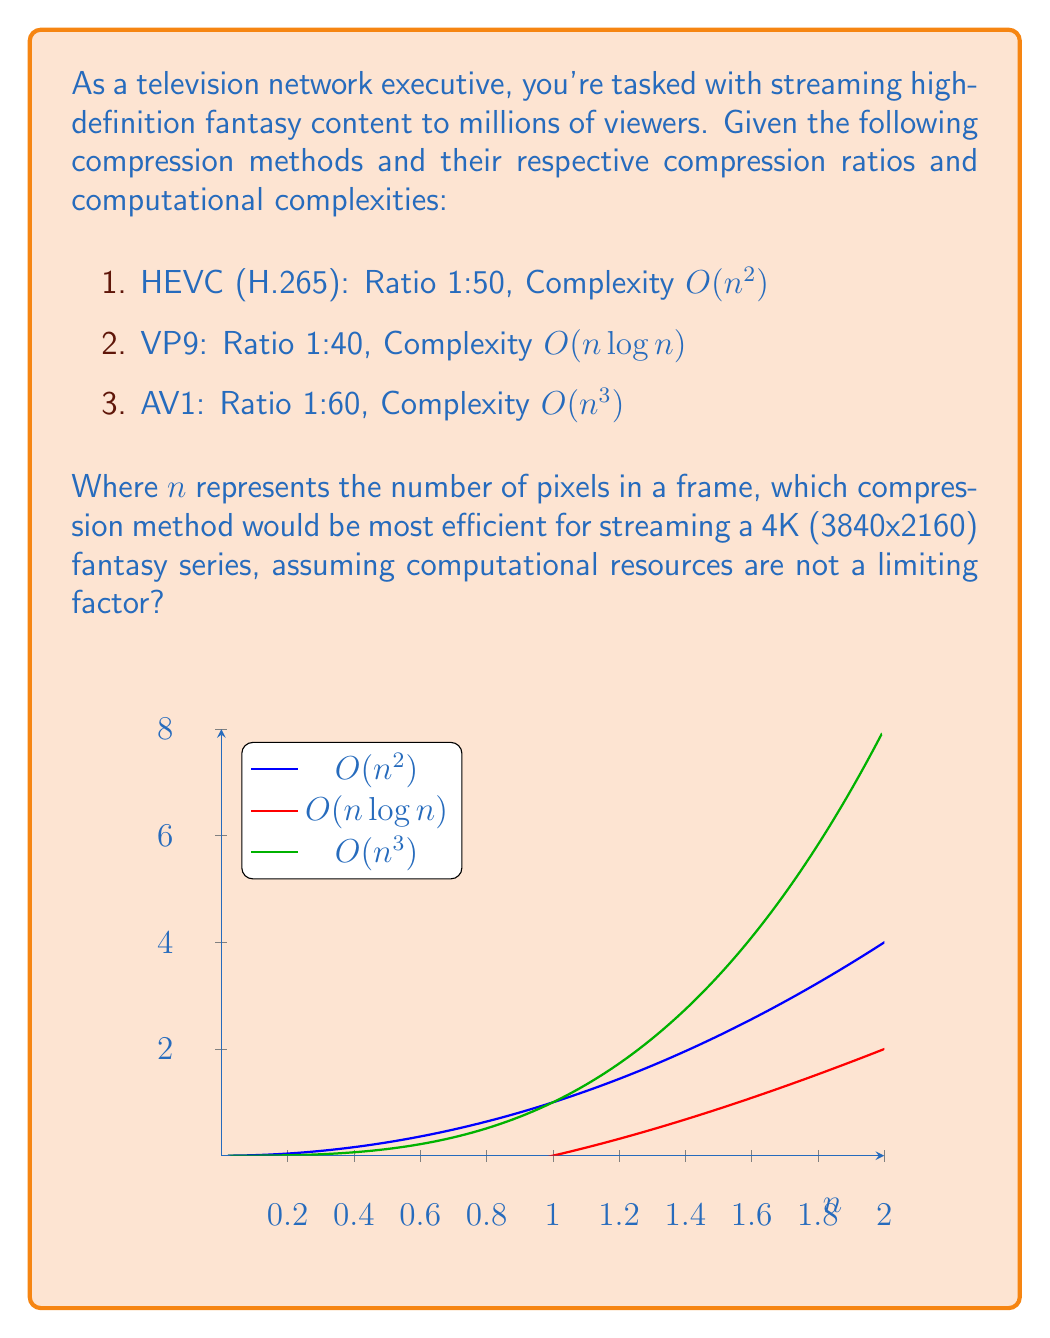What is the answer to this math problem? To determine the most efficient compression method, we need to consider both the compression ratio and the computational complexity. Since computational resources are not a limiting factor, we'll focus primarily on the compression ratio.

Step 1: Calculate the number of pixels in a 4K frame.
$n = 3840 \times 2160 = 8,294,400$ pixels

Step 2: Compare compression ratios:
1. HEVC (H.265): 1:50
2. VP9: 1:40
3. AV1: 1:60

Step 3: Analyze the results:
AV1 has the highest compression ratio at 1:60, meaning it can compress the data the most effectively. This is crucial for streaming high-definition content, as it reduces bandwidth requirements and improves streaming quality.

Step 4: Consider computational complexity:
Although AV1 has the highest computational complexity at $O(n^3)$, we're told that computational resources are not a limiting factor. Therefore, we can prioritize compression efficiency over computational cost.

Step 5: Make the final decision:
Given that AV1 offers the best compression ratio and computational resources are not a concern, it would be the most efficient method for streaming high-definition fantasy content.
Answer: AV1 